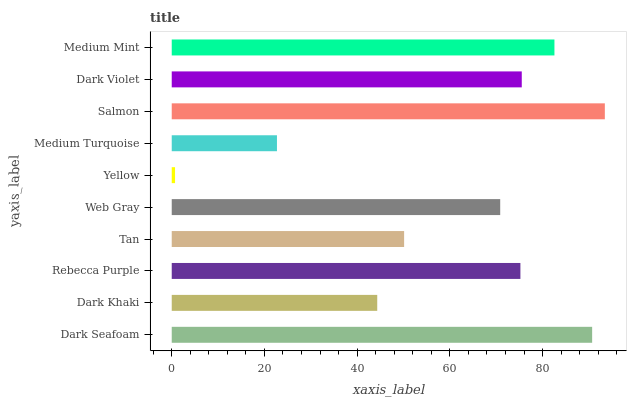Is Yellow the minimum?
Answer yes or no. Yes. Is Salmon the maximum?
Answer yes or no. Yes. Is Dark Khaki the minimum?
Answer yes or no. No. Is Dark Khaki the maximum?
Answer yes or no. No. Is Dark Seafoam greater than Dark Khaki?
Answer yes or no. Yes. Is Dark Khaki less than Dark Seafoam?
Answer yes or no. Yes. Is Dark Khaki greater than Dark Seafoam?
Answer yes or no. No. Is Dark Seafoam less than Dark Khaki?
Answer yes or no. No. Is Rebecca Purple the high median?
Answer yes or no. Yes. Is Web Gray the low median?
Answer yes or no. Yes. Is Web Gray the high median?
Answer yes or no. No. Is Medium Mint the low median?
Answer yes or no. No. 